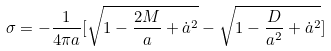Convert formula to latex. <formula><loc_0><loc_0><loc_500><loc_500>\sigma = - \frac { 1 } { 4 \pi a } [ \sqrt { 1 - \frac { 2 M } { a } + \dot { a } ^ { 2 } } - \sqrt { 1 - \frac { D } { a ^ { 2 } } + \dot { a } ^ { 2 } } ]</formula> 